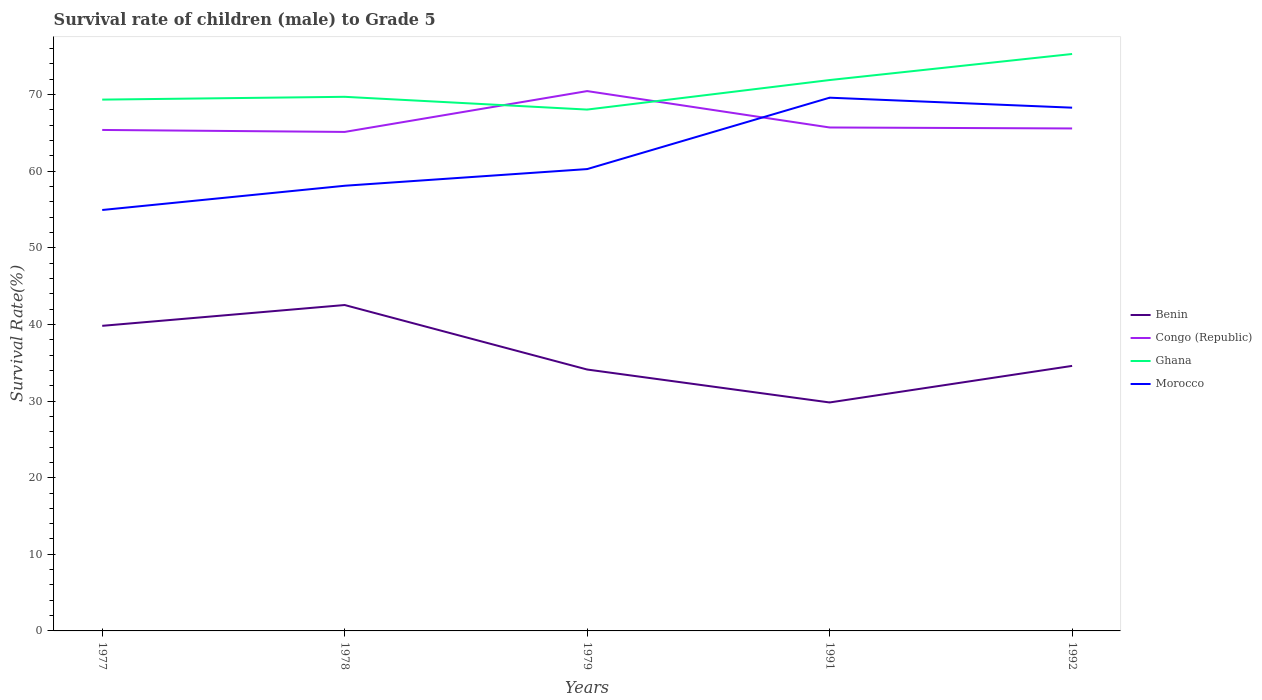How many different coloured lines are there?
Keep it short and to the point. 4. Is the number of lines equal to the number of legend labels?
Make the answer very short. Yes. Across all years, what is the maximum survival rate of male children to grade 5 in Morocco?
Provide a succinct answer. 54.94. In which year was the survival rate of male children to grade 5 in Benin maximum?
Make the answer very short. 1991. What is the total survival rate of male children to grade 5 in Morocco in the graph?
Keep it short and to the point. -8.02. What is the difference between the highest and the second highest survival rate of male children to grade 5 in Congo (Republic)?
Your response must be concise. 5.33. Is the survival rate of male children to grade 5 in Morocco strictly greater than the survival rate of male children to grade 5 in Congo (Republic) over the years?
Make the answer very short. No. How many years are there in the graph?
Offer a terse response. 5. Are the values on the major ticks of Y-axis written in scientific E-notation?
Your answer should be compact. No. Does the graph contain any zero values?
Your answer should be very brief. No. How many legend labels are there?
Your answer should be very brief. 4. How are the legend labels stacked?
Your answer should be very brief. Vertical. What is the title of the graph?
Offer a very short reply. Survival rate of children (male) to Grade 5. Does "Venezuela" appear as one of the legend labels in the graph?
Your answer should be very brief. No. What is the label or title of the X-axis?
Your response must be concise. Years. What is the label or title of the Y-axis?
Keep it short and to the point. Survival Rate(%). What is the Survival Rate(%) in Benin in 1977?
Ensure brevity in your answer.  39.82. What is the Survival Rate(%) in Congo (Republic) in 1977?
Your response must be concise. 65.39. What is the Survival Rate(%) in Ghana in 1977?
Offer a terse response. 69.35. What is the Survival Rate(%) of Morocco in 1977?
Your answer should be very brief. 54.94. What is the Survival Rate(%) in Benin in 1978?
Your response must be concise. 42.54. What is the Survival Rate(%) of Congo (Republic) in 1978?
Give a very brief answer. 65.13. What is the Survival Rate(%) of Ghana in 1978?
Your response must be concise. 69.71. What is the Survival Rate(%) of Morocco in 1978?
Provide a short and direct response. 58.1. What is the Survival Rate(%) in Benin in 1979?
Your answer should be very brief. 34.12. What is the Survival Rate(%) in Congo (Republic) in 1979?
Your response must be concise. 70.46. What is the Survival Rate(%) in Ghana in 1979?
Provide a short and direct response. 68.05. What is the Survival Rate(%) of Morocco in 1979?
Give a very brief answer. 60.28. What is the Survival Rate(%) of Benin in 1991?
Keep it short and to the point. 29.82. What is the Survival Rate(%) in Congo (Republic) in 1991?
Ensure brevity in your answer.  65.71. What is the Survival Rate(%) of Ghana in 1991?
Your answer should be compact. 71.9. What is the Survival Rate(%) of Morocco in 1991?
Ensure brevity in your answer.  69.6. What is the Survival Rate(%) in Benin in 1992?
Provide a short and direct response. 34.59. What is the Survival Rate(%) of Congo (Republic) in 1992?
Offer a terse response. 65.58. What is the Survival Rate(%) in Ghana in 1992?
Offer a terse response. 75.3. What is the Survival Rate(%) of Morocco in 1992?
Give a very brief answer. 68.3. Across all years, what is the maximum Survival Rate(%) in Benin?
Ensure brevity in your answer.  42.54. Across all years, what is the maximum Survival Rate(%) in Congo (Republic)?
Give a very brief answer. 70.46. Across all years, what is the maximum Survival Rate(%) of Ghana?
Offer a terse response. 75.3. Across all years, what is the maximum Survival Rate(%) of Morocco?
Make the answer very short. 69.6. Across all years, what is the minimum Survival Rate(%) in Benin?
Give a very brief answer. 29.82. Across all years, what is the minimum Survival Rate(%) of Congo (Republic)?
Provide a short and direct response. 65.13. Across all years, what is the minimum Survival Rate(%) of Ghana?
Your answer should be compact. 68.05. Across all years, what is the minimum Survival Rate(%) in Morocco?
Your answer should be very brief. 54.94. What is the total Survival Rate(%) in Benin in the graph?
Give a very brief answer. 180.89. What is the total Survival Rate(%) of Congo (Republic) in the graph?
Ensure brevity in your answer.  332.28. What is the total Survival Rate(%) in Ghana in the graph?
Keep it short and to the point. 354.31. What is the total Survival Rate(%) of Morocco in the graph?
Keep it short and to the point. 311.22. What is the difference between the Survival Rate(%) in Benin in 1977 and that in 1978?
Your response must be concise. -2.72. What is the difference between the Survival Rate(%) of Congo (Republic) in 1977 and that in 1978?
Provide a succinct answer. 0.26. What is the difference between the Survival Rate(%) in Ghana in 1977 and that in 1978?
Offer a terse response. -0.37. What is the difference between the Survival Rate(%) in Morocco in 1977 and that in 1978?
Your answer should be very brief. -3.16. What is the difference between the Survival Rate(%) in Benin in 1977 and that in 1979?
Your answer should be compact. 5.7. What is the difference between the Survival Rate(%) of Congo (Republic) in 1977 and that in 1979?
Ensure brevity in your answer.  -5.07. What is the difference between the Survival Rate(%) of Ghana in 1977 and that in 1979?
Ensure brevity in your answer.  1.3. What is the difference between the Survival Rate(%) in Morocco in 1977 and that in 1979?
Offer a terse response. -5.34. What is the difference between the Survival Rate(%) in Benin in 1977 and that in 1991?
Give a very brief answer. 10. What is the difference between the Survival Rate(%) in Congo (Republic) in 1977 and that in 1991?
Your answer should be very brief. -0.32. What is the difference between the Survival Rate(%) in Ghana in 1977 and that in 1991?
Offer a terse response. -2.55. What is the difference between the Survival Rate(%) of Morocco in 1977 and that in 1991?
Your answer should be very brief. -14.66. What is the difference between the Survival Rate(%) in Benin in 1977 and that in 1992?
Give a very brief answer. 5.23. What is the difference between the Survival Rate(%) in Congo (Republic) in 1977 and that in 1992?
Your answer should be compact. -0.2. What is the difference between the Survival Rate(%) of Ghana in 1977 and that in 1992?
Provide a succinct answer. -5.95. What is the difference between the Survival Rate(%) in Morocco in 1977 and that in 1992?
Provide a short and direct response. -13.36. What is the difference between the Survival Rate(%) of Benin in 1978 and that in 1979?
Provide a succinct answer. 8.42. What is the difference between the Survival Rate(%) of Congo (Republic) in 1978 and that in 1979?
Make the answer very short. -5.33. What is the difference between the Survival Rate(%) of Ghana in 1978 and that in 1979?
Provide a succinct answer. 1.67. What is the difference between the Survival Rate(%) in Morocco in 1978 and that in 1979?
Offer a terse response. -2.18. What is the difference between the Survival Rate(%) in Benin in 1978 and that in 1991?
Provide a short and direct response. 12.72. What is the difference between the Survival Rate(%) in Congo (Republic) in 1978 and that in 1991?
Give a very brief answer. -0.58. What is the difference between the Survival Rate(%) of Ghana in 1978 and that in 1991?
Your response must be concise. -2.19. What is the difference between the Survival Rate(%) of Morocco in 1978 and that in 1991?
Your answer should be very brief. -11.49. What is the difference between the Survival Rate(%) of Benin in 1978 and that in 1992?
Offer a very short reply. 7.94. What is the difference between the Survival Rate(%) of Congo (Republic) in 1978 and that in 1992?
Keep it short and to the point. -0.45. What is the difference between the Survival Rate(%) in Ghana in 1978 and that in 1992?
Offer a very short reply. -5.59. What is the difference between the Survival Rate(%) of Morocco in 1978 and that in 1992?
Your response must be concise. -10.19. What is the difference between the Survival Rate(%) of Benin in 1979 and that in 1991?
Provide a succinct answer. 4.3. What is the difference between the Survival Rate(%) in Congo (Republic) in 1979 and that in 1991?
Provide a succinct answer. 4.75. What is the difference between the Survival Rate(%) of Ghana in 1979 and that in 1991?
Make the answer very short. -3.85. What is the difference between the Survival Rate(%) of Morocco in 1979 and that in 1991?
Ensure brevity in your answer.  -9.32. What is the difference between the Survival Rate(%) of Benin in 1979 and that in 1992?
Keep it short and to the point. -0.47. What is the difference between the Survival Rate(%) of Congo (Republic) in 1979 and that in 1992?
Your response must be concise. 4.88. What is the difference between the Survival Rate(%) in Ghana in 1979 and that in 1992?
Ensure brevity in your answer.  -7.25. What is the difference between the Survival Rate(%) in Morocco in 1979 and that in 1992?
Offer a very short reply. -8.02. What is the difference between the Survival Rate(%) of Benin in 1991 and that in 1992?
Your answer should be very brief. -4.77. What is the difference between the Survival Rate(%) in Congo (Republic) in 1991 and that in 1992?
Keep it short and to the point. 0.13. What is the difference between the Survival Rate(%) in Ghana in 1991 and that in 1992?
Your answer should be compact. -3.4. What is the difference between the Survival Rate(%) of Morocco in 1991 and that in 1992?
Provide a short and direct response. 1.3. What is the difference between the Survival Rate(%) in Benin in 1977 and the Survival Rate(%) in Congo (Republic) in 1978?
Provide a short and direct response. -25.31. What is the difference between the Survival Rate(%) in Benin in 1977 and the Survival Rate(%) in Ghana in 1978?
Your response must be concise. -29.89. What is the difference between the Survival Rate(%) of Benin in 1977 and the Survival Rate(%) of Morocco in 1978?
Make the answer very short. -18.28. What is the difference between the Survival Rate(%) of Congo (Republic) in 1977 and the Survival Rate(%) of Ghana in 1978?
Keep it short and to the point. -4.33. What is the difference between the Survival Rate(%) in Congo (Republic) in 1977 and the Survival Rate(%) in Morocco in 1978?
Make the answer very short. 7.28. What is the difference between the Survival Rate(%) in Ghana in 1977 and the Survival Rate(%) in Morocco in 1978?
Give a very brief answer. 11.24. What is the difference between the Survival Rate(%) of Benin in 1977 and the Survival Rate(%) of Congo (Republic) in 1979?
Your response must be concise. -30.64. What is the difference between the Survival Rate(%) of Benin in 1977 and the Survival Rate(%) of Ghana in 1979?
Your answer should be very brief. -28.23. What is the difference between the Survival Rate(%) in Benin in 1977 and the Survival Rate(%) in Morocco in 1979?
Your answer should be compact. -20.46. What is the difference between the Survival Rate(%) in Congo (Republic) in 1977 and the Survival Rate(%) in Ghana in 1979?
Make the answer very short. -2.66. What is the difference between the Survival Rate(%) in Congo (Republic) in 1977 and the Survival Rate(%) in Morocco in 1979?
Provide a short and direct response. 5.11. What is the difference between the Survival Rate(%) of Ghana in 1977 and the Survival Rate(%) of Morocco in 1979?
Offer a very short reply. 9.07. What is the difference between the Survival Rate(%) of Benin in 1977 and the Survival Rate(%) of Congo (Republic) in 1991?
Your answer should be very brief. -25.89. What is the difference between the Survival Rate(%) in Benin in 1977 and the Survival Rate(%) in Ghana in 1991?
Provide a short and direct response. -32.08. What is the difference between the Survival Rate(%) in Benin in 1977 and the Survival Rate(%) in Morocco in 1991?
Provide a succinct answer. -29.78. What is the difference between the Survival Rate(%) of Congo (Republic) in 1977 and the Survival Rate(%) of Ghana in 1991?
Your response must be concise. -6.51. What is the difference between the Survival Rate(%) of Congo (Republic) in 1977 and the Survival Rate(%) of Morocco in 1991?
Your answer should be very brief. -4.21. What is the difference between the Survival Rate(%) of Ghana in 1977 and the Survival Rate(%) of Morocco in 1991?
Offer a very short reply. -0.25. What is the difference between the Survival Rate(%) in Benin in 1977 and the Survival Rate(%) in Congo (Republic) in 1992?
Your answer should be very brief. -25.76. What is the difference between the Survival Rate(%) of Benin in 1977 and the Survival Rate(%) of Ghana in 1992?
Your response must be concise. -35.48. What is the difference between the Survival Rate(%) of Benin in 1977 and the Survival Rate(%) of Morocco in 1992?
Ensure brevity in your answer.  -28.48. What is the difference between the Survival Rate(%) of Congo (Republic) in 1977 and the Survival Rate(%) of Ghana in 1992?
Ensure brevity in your answer.  -9.91. What is the difference between the Survival Rate(%) in Congo (Republic) in 1977 and the Survival Rate(%) in Morocco in 1992?
Provide a short and direct response. -2.91. What is the difference between the Survival Rate(%) in Ghana in 1977 and the Survival Rate(%) in Morocco in 1992?
Make the answer very short. 1.05. What is the difference between the Survival Rate(%) in Benin in 1978 and the Survival Rate(%) in Congo (Republic) in 1979?
Offer a terse response. -27.92. What is the difference between the Survival Rate(%) in Benin in 1978 and the Survival Rate(%) in Ghana in 1979?
Offer a very short reply. -25.51. What is the difference between the Survival Rate(%) in Benin in 1978 and the Survival Rate(%) in Morocco in 1979?
Offer a terse response. -17.74. What is the difference between the Survival Rate(%) of Congo (Republic) in 1978 and the Survival Rate(%) of Ghana in 1979?
Offer a terse response. -2.92. What is the difference between the Survival Rate(%) of Congo (Republic) in 1978 and the Survival Rate(%) of Morocco in 1979?
Offer a very short reply. 4.85. What is the difference between the Survival Rate(%) in Ghana in 1978 and the Survival Rate(%) in Morocco in 1979?
Provide a short and direct response. 9.43. What is the difference between the Survival Rate(%) in Benin in 1978 and the Survival Rate(%) in Congo (Republic) in 1991?
Your answer should be compact. -23.17. What is the difference between the Survival Rate(%) of Benin in 1978 and the Survival Rate(%) of Ghana in 1991?
Make the answer very short. -29.36. What is the difference between the Survival Rate(%) in Benin in 1978 and the Survival Rate(%) in Morocco in 1991?
Offer a very short reply. -27.06. What is the difference between the Survival Rate(%) of Congo (Republic) in 1978 and the Survival Rate(%) of Ghana in 1991?
Keep it short and to the point. -6.77. What is the difference between the Survival Rate(%) in Congo (Republic) in 1978 and the Survival Rate(%) in Morocco in 1991?
Make the answer very short. -4.47. What is the difference between the Survival Rate(%) of Ghana in 1978 and the Survival Rate(%) of Morocco in 1991?
Provide a succinct answer. 0.11. What is the difference between the Survival Rate(%) of Benin in 1978 and the Survival Rate(%) of Congo (Republic) in 1992?
Give a very brief answer. -23.05. What is the difference between the Survival Rate(%) of Benin in 1978 and the Survival Rate(%) of Ghana in 1992?
Make the answer very short. -32.76. What is the difference between the Survival Rate(%) of Benin in 1978 and the Survival Rate(%) of Morocco in 1992?
Your response must be concise. -25.76. What is the difference between the Survival Rate(%) of Congo (Republic) in 1978 and the Survival Rate(%) of Ghana in 1992?
Give a very brief answer. -10.17. What is the difference between the Survival Rate(%) of Congo (Republic) in 1978 and the Survival Rate(%) of Morocco in 1992?
Give a very brief answer. -3.17. What is the difference between the Survival Rate(%) of Ghana in 1978 and the Survival Rate(%) of Morocco in 1992?
Offer a terse response. 1.42. What is the difference between the Survival Rate(%) of Benin in 1979 and the Survival Rate(%) of Congo (Republic) in 1991?
Give a very brief answer. -31.59. What is the difference between the Survival Rate(%) in Benin in 1979 and the Survival Rate(%) in Ghana in 1991?
Offer a very short reply. -37.78. What is the difference between the Survival Rate(%) of Benin in 1979 and the Survival Rate(%) of Morocco in 1991?
Your response must be concise. -35.48. What is the difference between the Survival Rate(%) of Congo (Republic) in 1979 and the Survival Rate(%) of Ghana in 1991?
Your response must be concise. -1.44. What is the difference between the Survival Rate(%) of Congo (Republic) in 1979 and the Survival Rate(%) of Morocco in 1991?
Provide a short and direct response. 0.86. What is the difference between the Survival Rate(%) of Ghana in 1979 and the Survival Rate(%) of Morocco in 1991?
Provide a succinct answer. -1.55. What is the difference between the Survival Rate(%) of Benin in 1979 and the Survival Rate(%) of Congo (Republic) in 1992?
Your answer should be compact. -31.47. What is the difference between the Survival Rate(%) of Benin in 1979 and the Survival Rate(%) of Ghana in 1992?
Provide a short and direct response. -41.18. What is the difference between the Survival Rate(%) in Benin in 1979 and the Survival Rate(%) in Morocco in 1992?
Ensure brevity in your answer.  -34.18. What is the difference between the Survival Rate(%) of Congo (Republic) in 1979 and the Survival Rate(%) of Ghana in 1992?
Provide a short and direct response. -4.84. What is the difference between the Survival Rate(%) in Congo (Republic) in 1979 and the Survival Rate(%) in Morocco in 1992?
Give a very brief answer. 2.16. What is the difference between the Survival Rate(%) in Ghana in 1979 and the Survival Rate(%) in Morocco in 1992?
Your response must be concise. -0.25. What is the difference between the Survival Rate(%) in Benin in 1991 and the Survival Rate(%) in Congo (Republic) in 1992?
Your response must be concise. -35.76. What is the difference between the Survival Rate(%) of Benin in 1991 and the Survival Rate(%) of Ghana in 1992?
Offer a terse response. -45.48. What is the difference between the Survival Rate(%) of Benin in 1991 and the Survival Rate(%) of Morocco in 1992?
Provide a succinct answer. -38.48. What is the difference between the Survival Rate(%) in Congo (Republic) in 1991 and the Survival Rate(%) in Ghana in 1992?
Keep it short and to the point. -9.59. What is the difference between the Survival Rate(%) of Congo (Republic) in 1991 and the Survival Rate(%) of Morocco in 1992?
Provide a short and direct response. -2.59. What is the difference between the Survival Rate(%) of Ghana in 1991 and the Survival Rate(%) of Morocco in 1992?
Offer a terse response. 3.61. What is the average Survival Rate(%) in Benin per year?
Offer a terse response. 36.18. What is the average Survival Rate(%) of Congo (Republic) per year?
Ensure brevity in your answer.  66.46. What is the average Survival Rate(%) in Ghana per year?
Offer a very short reply. 70.86. What is the average Survival Rate(%) of Morocco per year?
Keep it short and to the point. 62.24. In the year 1977, what is the difference between the Survival Rate(%) in Benin and Survival Rate(%) in Congo (Republic)?
Your answer should be very brief. -25.57. In the year 1977, what is the difference between the Survival Rate(%) of Benin and Survival Rate(%) of Ghana?
Your response must be concise. -29.53. In the year 1977, what is the difference between the Survival Rate(%) in Benin and Survival Rate(%) in Morocco?
Ensure brevity in your answer.  -15.12. In the year 1977, what is the difference between the Survival Rate(%) in Congo (Republic) and Survival Rate(%) in Ghana?
Offer a terse response. -3.96. In the year 1977, what is the difference between the Survival Rate(%) in Congo (Republic) and Survival Rate(%) in Morocco?
Keep it short and to the point. 10.45. In the year 1977, what is the difference between the Survival Rate(%) of Ghana and Survival Rate(%) of Morocco?
Provide a short and direct response. 14.41. In the year 1978, what is the difference between the Survival Rate(%) of Benin and Survival Rate(%) of Congo (Republic)?
Your answer should be compact. -22.59. In the year 1978, what is the difference between the Survival Rate(%) in Benin and Survival Rate(%) in Ghana?
Your answer should be compact. -27.18. In the year 1978, what is the difference between the Survival Rate(%) in Benin and Survival Rate(%) in Morocco?
Provide a short and direct response. -15.57. In the year 1978, what is the difference between the Survival Rate(%) in Congo (Republic) and Survival Rate(%) in Ghana?
Offer a very short reply. -4.58. In the year 1978, what is the difference between the Survival Rate(%) of Congo (Republic) and Survival Rate(%) of Morocco?
Give a very brief answer. 7.03. In the year 1978, what is the difference between the Survival Rate(%) of Ghana and Survival Rate(%) of Morocco?
Offer a very short reply. 11.61. In the year 1979, what is the difference between the Survival Rate(%) of Benin and Survival Rate(%) of Congo (Republic)?
Provide a short and direct response. -36.34. In the year 1979, what is the difference between the Survival Rate(%) in Benin and Survival Rate(%) in Ghana?
Provide a short and direct response. -33.93. In the year 1979, what is the difference between the Survival Rate(%) in Benin and Survival Rate(%) in Morocco?
Make the answer very short. -26.16. In the year 1979, what is the difference between the Survival Rate(%) in Congo (Republic) and Survival Rate(%) in Ghana?
Make the answer very short. 2.41. In the year 1979, what is the difference between the Survival Rate(%) of Congo (Republic) and Survival Rate(%) of Morocco?
Give a very brief answer. 10.18. In the year 1979, what is the difference between the Survival Rate(%) in Ghana and Survival Rate(%) in Morocco?
Give a very brief answer. 7.77. In the year 1991, what is the difference between the Survival Rate(%) of Benin and Survival Rate(%) of Congo (Republic)?
Your answer should be very brief. -35.89. In the year 1991, what is the difference between the Survival Rate(%) in Benin and Survival Rate(%) in Ghana?
Your answer should be compact. -42.08. In the year 1991, what is the difference between the Survival Rate(%) of Benin and Survival Rate(%) of Morocco?
Provide a short and direct response. -39.78. In the year 1991, what is the difference between the Survival Rate(%) of Congo (Republic) and Survival Rate(%) of Ghana?
Offer a terse response. -6.19. In the year 1991, what is the difference between the Survival Rate(%) of Congo (Republic) and Survival Rate(%) of Morocco?
Provide a short and direct response. -3.89. In the year 1991, what is the difference between the Survival Rate(%) of Ghana and Survival Rate(%) of Morocco?
Your answer should be very brief. 2.3. In the year 1992, what is the difference between the Survival Rate(%) of Benin and Survival Rate(%) of Congo (Republic)?
Provide a succinct answer. -30.99. In the year 1992, what is the difference between the Survival Rate(%) of Benin and Survival Rate(%) of Ghana?
Your answer should be compact. -40.71. In the year 1992, what is the difference between the Survival Rate(%) in Benin and Survival Rate(%) in Morocco?
Give a very brief answer. -33.7. In the year 1992, what is the difference between the Survival Rate(%) in Congo (Republic) and Survival Rate(%) in Ghana?
Make the answer very short. -9.72. In the year 1992, what is the difference between the Survival Rate(%) of Congo (Republic) and Survival Rate(%) of Morocco?
Offer a terse response. -2.71. In the year 1992, what is the difference between the Survival Rate(%) of Ghana and Survival Rate(%) of Morocco?
Ensure brevity in your answer.  7.01. What is the ratio of the Survival Rate(%) of Benin in 1977 to that in 1978?
Make the answer very short. 0.94. What is the ratio of the Survival Rate(%) in Congo (Republic) in 1977 to that in 1978?
Your answer should be very brief. 1. What is the ratio of the Survival Rate(%) in Ghana in 1977 to that in 1978?
Provide a succinct answer. 0.99. What is the ratio of the Survival Rate(%) in Morocco in 1977 to that in 1978?
Your answer should be very brief. 0.95. What is the ratio of the Survival Rate(%) of Benin in 1977 to that in 1979?
Give a very brief answer. 1.17. What is the ratio of the Survival Rate(%) of Congo (Republic) in 1977 to that in 1979?
Keep it short and to the point. 0.93. What is the ratio of the Survival Rate(%) of Ghana in 1977 to that in 1979?
Offer a terse response. 1.02. What is the ratio of the Survival Rate(%) of Morocco in 1977 to that in 1979?
Offer a very short reply. 0.91. What is the ratio of the Survival Rate(%) of Benin in 1977 to that in 1991?
Offer a very short reply. 1.34. What is the ratio of the Survival Rate(%) in Ghana in 1977 to that in 1991?
Your response must be concise. 0.96. What is the ratio of the Survival Rate(%) in Morocco in 1977 to that in 1991?
Your answer should be compact. 0.79. What is the ratio of the Survival Rate(%) in Benin in 1977 to that in 1992?
Offer a very short reply. 1.15. What is the ratio of the Survival Rate(%) of Ghana in 1977 to that in 1992?
Offer a very short reply. 0.92. What is the ratio of the Survival Rate(%) in Morocco in 1977 to that in 1992?
Ensure brevity in your answer.  0.8. What is the ratio of the Survival Rate(%) in Benin in 1978 to that in 1979?
Your answer should be compact. 1.25. What is the ratio of the Survival Rate(%) in Congo (Republic) in 1978 to that in 1979?
Ensure brevity in your answer.  0.92. What is the ratio of the Survival Rate(%) in Ghana in 1978 to that in 1979?
Ensure brevity in your answer.  1.02. What is the ratio of the Survival Rate(%) of Morocco in 1978 to that in 1979?
Make the answer very short. 0.96. What is the ratio of the Survival Rate(%) of Benin in 1978 to that in 1991?
Give a very brief answer. 1.43. What is the ratio of the Survival Rate(%) of Ghana in 1978 to that in 1991?
Your response must be concise. 0.97. What is the ratio of the Survival Rate(%) of Morocco in 1978 to that in 1991?
Provide a short and direct response. 0.83. What is the ratio of the Survival Rate(%) of Benin in 1978 to that in 1992?
Give a very brief answer. 1.23. What is the ratio of the Survival Rate(%) of Congo (Republic) in 1978 to that in 1992?
Give a very brief answer. 0.99. What is the ratio of the Survival Rate(%) of Ghana in 1978 to that in 1992?
Your answer should be compact. 0.93. What is the ratio of the Survival Rate(%) in Morocco in 1978 to that in 1992?
Provide a succinct answer. 0.85. What is the ratio of the Survival Rate(%) of Benin in 1979 to that in 1991?
Your answer should be very brief. 1.14. What is the ratio of the Survival Rate(%) of Congo (Republic) in 1979 to that in 1991?
Offer a terse response. 1.07. What is the ratio of the Survival Rate(%) of Ghana in 1979 to that in 1991?
Your answer should be very brief. 0.95. What is the ratio of the Survival Rate(%) of Morocco in 1979 to that in 1991?
Make the answer very short. 0.87. What is the ratio of the Survival Rate(%) in Benin in 1979 to that in 1992?
Offer a very short reply. 0.99. What is the ratio of the Survival Rate(%) in Congo (Republic) in 1979 to that in 1992?
Your response must be concise. 1.07. What is the ratio of the Survival Rate(%) of Ghana in 1979 to that in 1992?
Make the answer very short. 0.9. What is the ratio of the Survival Rate(%) of Morocco in 1979 to that in 1992?
Keep it short and to the point. 0.88. What is the ratio of the Survival Rate(%) in Benin in 1991 to that in 1992?
Your answer should be compact. 0.86. What is the ratio of the Survival Rate(%) in Ghana in 1991 to that in 1992?
Your answer should be very brief. 0.95. What is the ratio of the Survival Rate(%) in Morocco in 1991 to that in 1992?
Offer a very short reply. 1.02. What is the difference between the highest and the second highest Survival Rate(%) in Benin?
Make the answer very short. 2.72. What is the difference between the highest and the second highest Survival Rate(%) in Congo (Republic)?
Give a very brief answer. 4.75. What is the difference between the highest and the second highest Survival Rate(%) of Ghana?
Make the answer very short. 3.4. What is the difference between the highest and the second highest Survival Rate(%) in Morocco?
Your response must be concise. 1.3. What is the difference between the highest and the lowest Survival Rate(%) of Benin?
Ensure brevity in your answer.  12.72. What is the difference between the highest and the lowest Survival Rate(%) in Congo (Republic)?
Provide a short and direct response. 5.33. What is the difference between the highest and the lowest Survival Rate(%) in Ghana?
Your answer should be very brief. 7.25. What is the difference between the highest and the lowest Survival Rate(%) of Morocco?
Give a very brief answer. 14.66. 